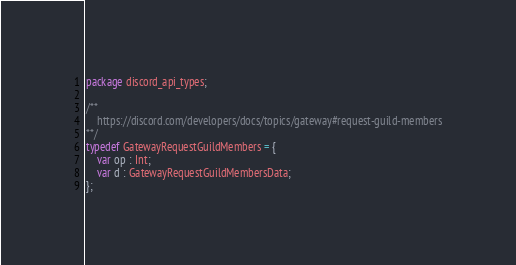Convert code to text. <code><loc_0><loc_0><loc_500><loc_500><_Haxe_>package discord_api_types;

/**
	https://discord.com/developers/docs/topics/gateway#request-guild-members
**/
typedef GatewayRequestGuildMembers = {
	var op : Int;
	var d : GatewayRequestGuildMembersData;
};</code> 